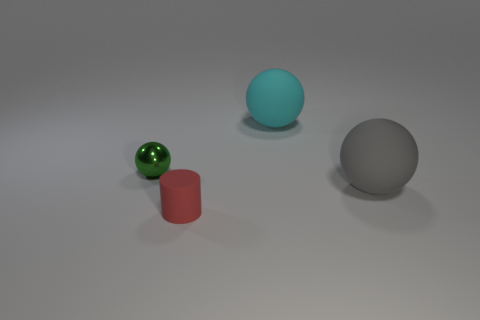Subtract all rubber balls. How many balls are left? 1 Subtract 1 spheres. How many spheres are left? 2 Add 1 cyan rubber spheres. How many objects exist? 5 Subtract all gray balls. How many balls are left? 2 Subtract all cylinders. How many objects are left? 3 Subtract all brown cylinders. Subtract all purple cubes. How many cylinders are left? 1 Subtract all cyan cylinders. How many green balls are left? 1 Subtract all big cyan rubber things. Subtract all large cyan things. How many objects are left? 2 Add 4 balls. How many balls are left? 7 Add 1 gray matte spheres. How many gray matte spheres exist? 2 